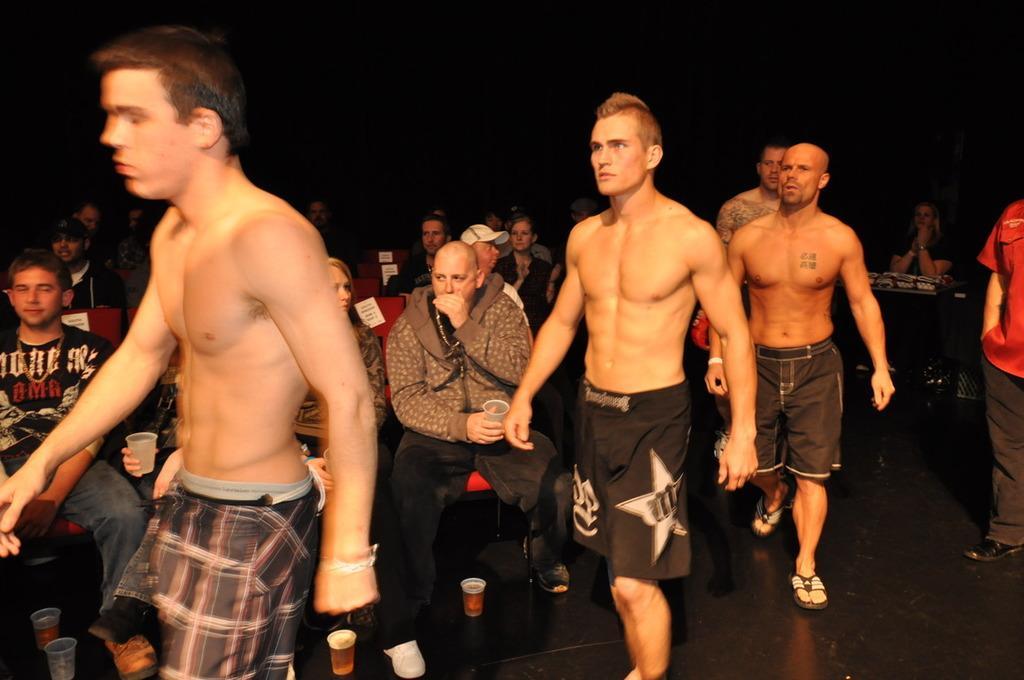Please provide a concise description of this image. In front of the image there are a few people walking, behind them there are a few other people sitting in chairs by holding glasses in their hands, on the surface there are some glasses of beer, on the right side of the image there is a person standing, behind him there is a woman sitting on the chair, in front of the woman on the table there are some objects. 